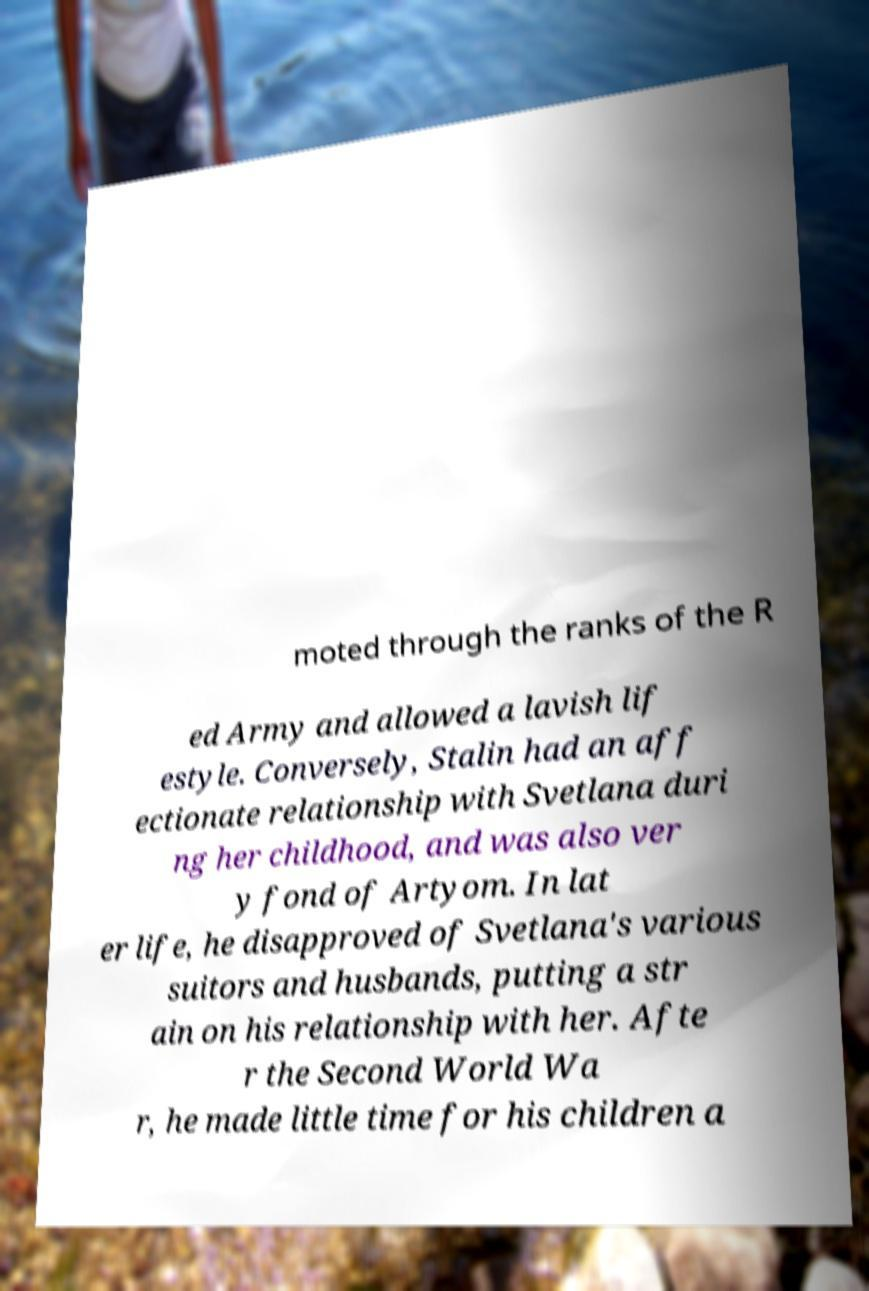Please read and relay the text visible in this image. What does it say? moted through the ranks of the R ed Army and allowed a lavish lif estyle. Conversely, Stalin had an aff ectionate relationship with Svetlana duri ng her childhood, and was also ver y fond of Artyom. In lat er life, he disapproved of Svetlana's various suitors and husbands, putting a str ain on his relationship with her. Afte r the Second World Wa r, he made little time for his children a 